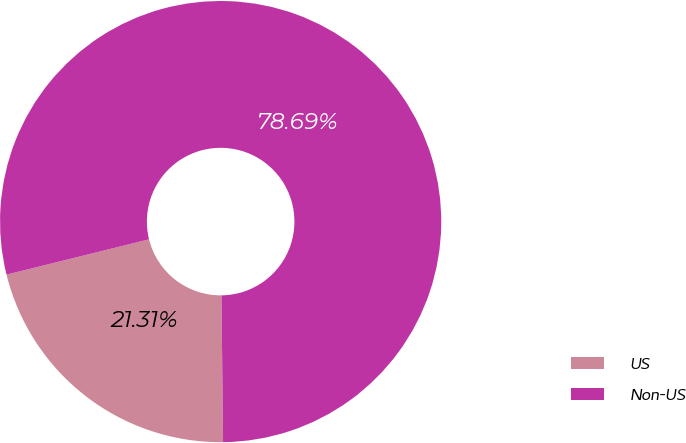Convert chart. <chart><loc_0><loc_0><loc_500><loc_500><pie_chart><fcel>US<fcel>Non-US<nl><fcel>21.31%<fcel>78.69%<nl></chart> 